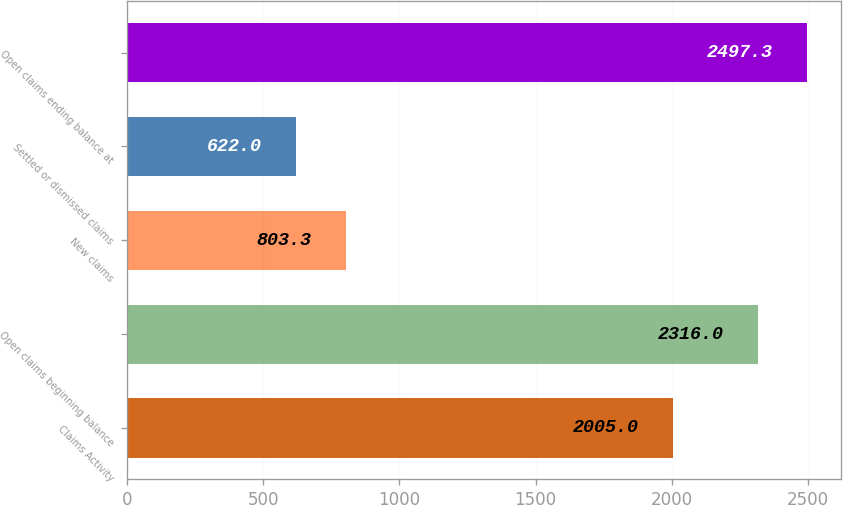<chart> <loc_0><loc_0><loc_500><loc_500><bar_chart><fcel>Claims Activity<fcel>Open claims beginning balance<fcel>New claims<fcel>Settled or dismissed claims<fcel>Open claims ending balance at<nl><fcel>2005<fcel>2316<fcel>803.3<fcel>622<fcel>2497.3<nl></chart> 